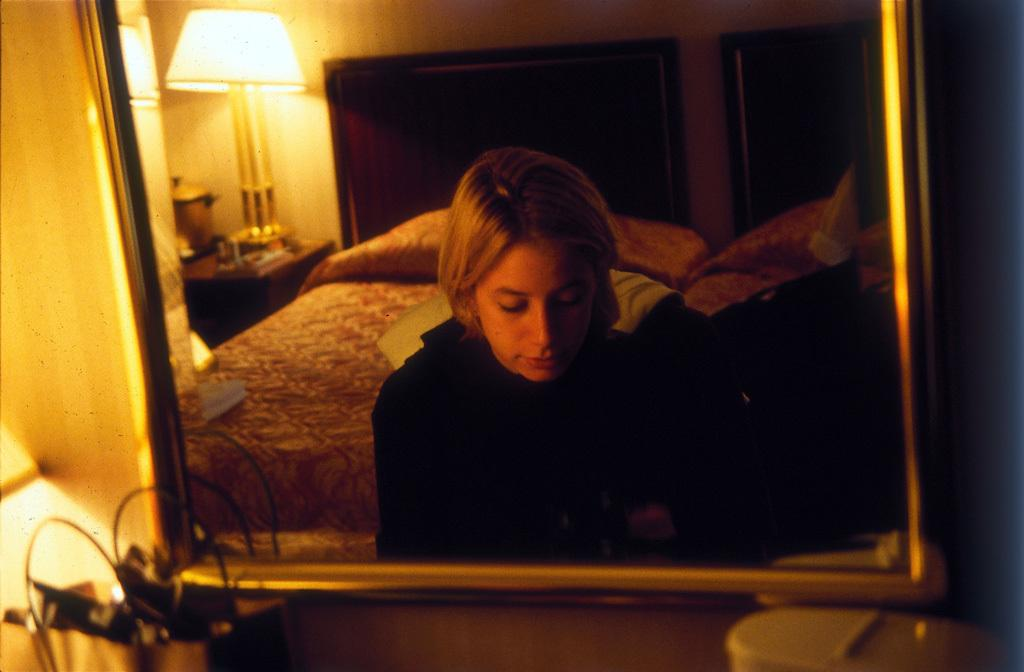What piece of furniture is present in the image? There is a desk in the image. What object is on the desk? There is a mirror on the desk. What does the mirror reflect? The mirror reflects a person, a bed, a lamp, the wall, and other objects. What type of appliance is visible in the mirror's reflection? There is no appliance visible in the mirror's reflection in the image. What color is the car that is parked in front of the desk? There is no car present in the image. 